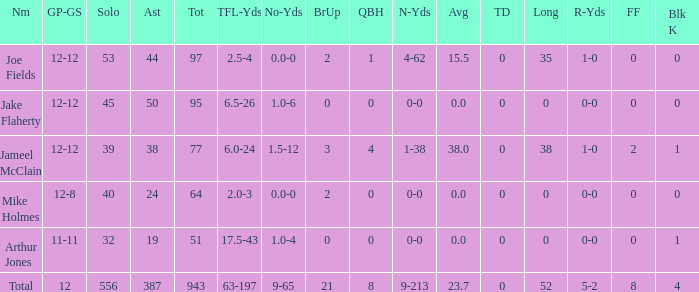What is the largest number of tds scored for a player? 0.0. 